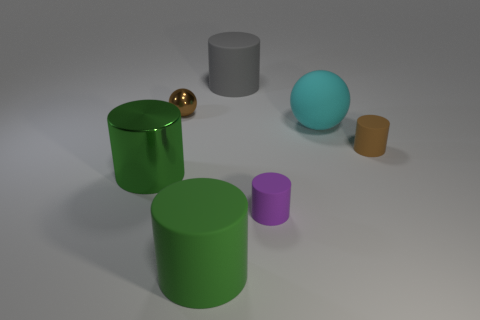There is a big gray matte thing that is left of the cylinder that is on the right side of the big sphere; are there any large green shiny cylinders that are in front of it?
Offer a terse response. Yes. There is a gray rubber object; are there any large green cylinders to the right of it?
Ensure brevity in your answer.  No. How many big rubber cylinders have the same color as the large metal cylinder?
Your response must be concise. 1. What is the size of the ball that is made of the same material as the small brown cylinder?
Keep it short and to the point. Large. What is the size of the green object in front of the large object that is left of the large green object to the right of the small shiny ball?
Make the answer very short. Large. There is a brown thing that is on the left side of the large cyan sphere; how big is it?
Keep it short and to the point. Small. How many brown objects are either tiny cylinders or small metallic cubes?
Provide a short and direct response. 1. Are there any matte objects of the same size as the brown cylinder?
Offer a terse response. Yes. There is a purple thing that is the same size as the brown rubber cylinder; what is its material?
Make the answer very short. Rubber. Does the shiny thing behind the cyan ball have the same size as the green cylinder in front of the small purple cylinder?
Your answer should be very brief. No. 